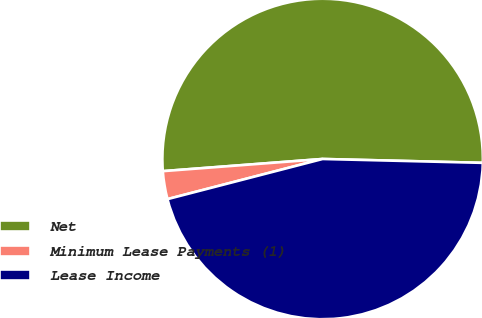Convert chart to OTSL. <chart><loc_0><loc_0><loc_500><loc_500><pie_chart><fcel>Net<fcel>Minimum Lease Payments (1)<fcel>Lease Income<nl><fcel>51.59%<fcel>2.82%<fcel>45.58%<nl></chart> 